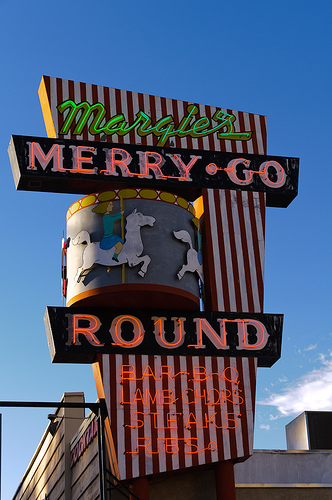<image>
Can you confirm if the horse is in the sign? Yes. The horse is contained within or inside the sign, showing a containment relationship. 